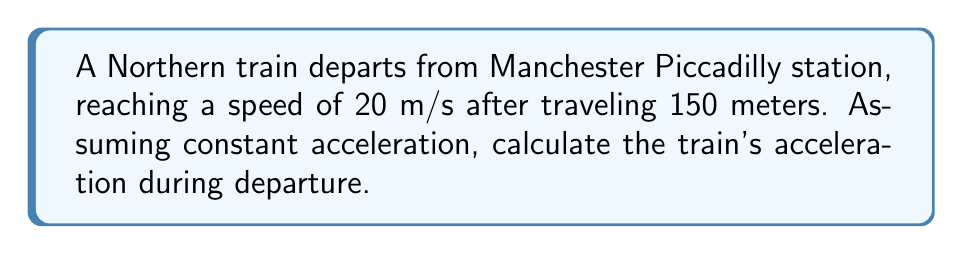Solve this math problem. To solve this problem, we'll use the equation relating displacement, initial velocity, final velocity, and acceleration:

$$v^2 = u^2 + 2as$$

Where:
$v$ = final velocity
$u$ = initial velocity
$a$ = acceleration
$s$ = displacement

Given:
- Initial velocity, $u = 0$ m/s (train starts from rest)
- Final velocity, $v = 20$ m/s
- Displacement, $s = 150$ m

Step 1: Substitute the known values into the equation:
$$(20)^2 = (0)^2 + 2a(150)$$

Step 2: Simplify:
$$400 = 300a$$

Step 3: Solve for acceleration:
$$a = \frac{400}{300} = \frac{4}{3} \approx 1.33 \text{ m/s}^2$$
Answer: $\frac{4}{3}$ m/s² 